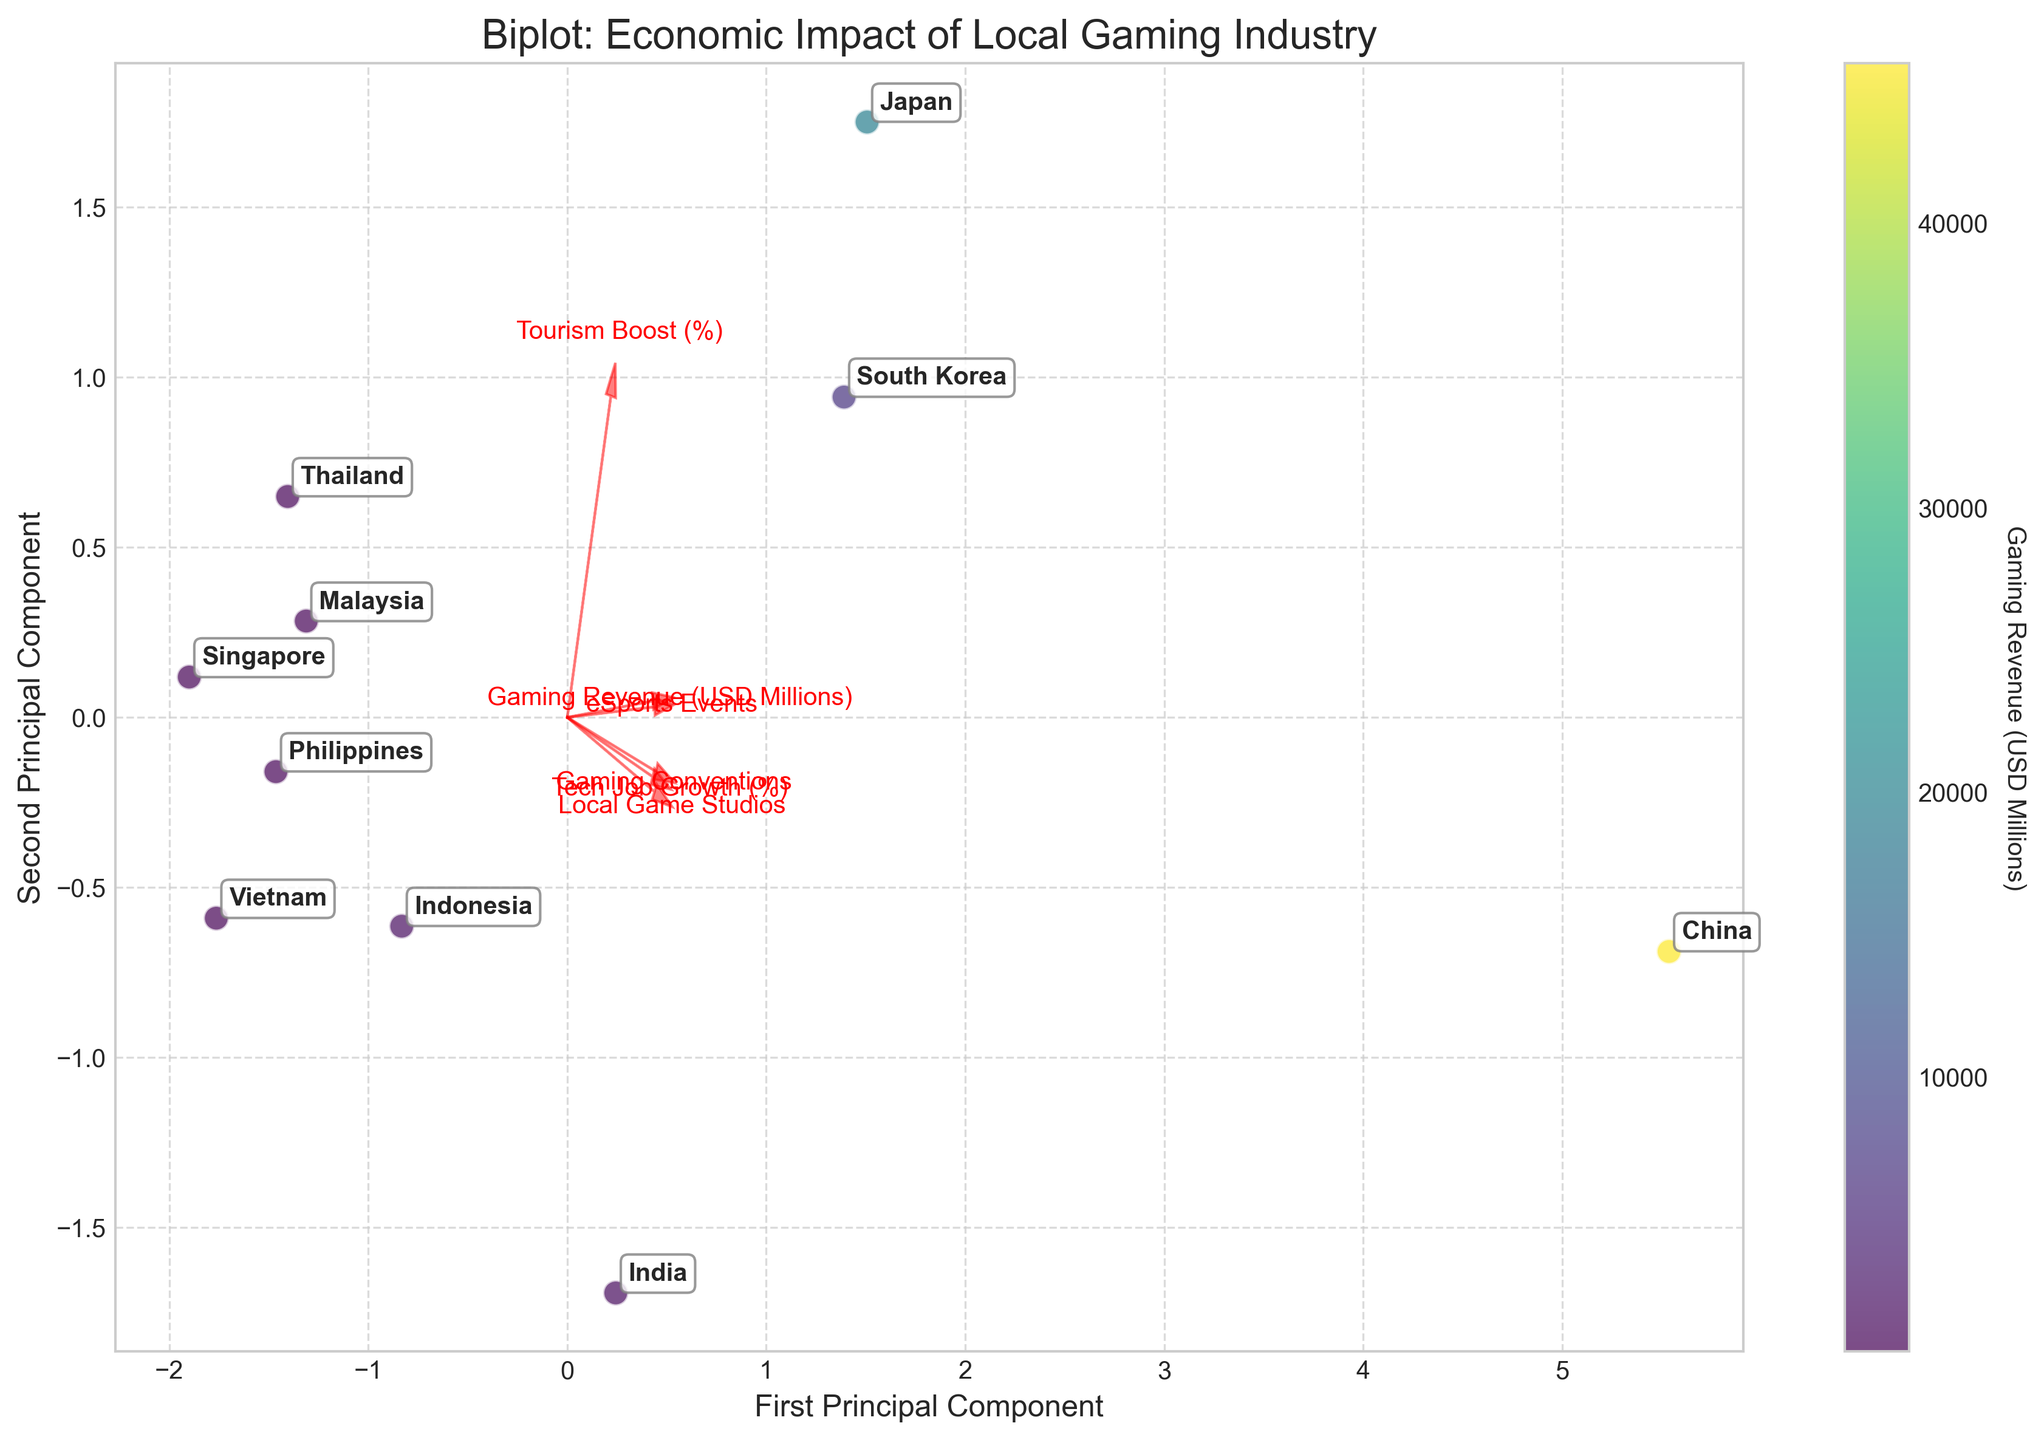What is the title of the plot? The title is usually placed at the top of the plot where it summarizes the main focus of the visualization in one line.
Answer: Biplot: Economic Impact of Local Gaming Industry How many countries are represented in the plot? Check the number of distinct annotations added on the plot for each data point representing a country.
Answer: 10 Which country has the highest gaming revenue based on the color map? Identify the data point with the deepest color corresponding to the highest value on the color map, and refer to its annotation.
Answer: China What are the labels of the axes? The labels are typically found along the sides of the plot; the x-axis label is at the bottom, and the y-axis label is on the left side.
Answer: First Principal Component and Second Principal Component Which feature is represented by the longest red arrow? The longest arrow indicates the feature with the greatest influence on the principal components. Identify the feature name next to this arrow.
Answer: Gaming Revenue (USD Millions) Which two countries seem to have the most similar impact according to the principal components? Look for data points that are closest to each other in the scatter plot as they share a similar projection in the PCA space.
Answer: Malaysia and Philippines What is the relationship between 'Tourism Boost (%)' and 'Local Game Studios'? Observe the directions of their arrows. If the arrows are aligned or pointing similarly, they are positively correlated; if reversed, negatively correlated. If perpendicular, they are uncorrelated.
Answer: Negatively correlated How many eSports Events does the country with the highest 'Tech Job Growth (%)' host? Identify which country has the highest value for 'Tech Job Growth (%)' based on the feature vector's direction ('Tech Job Growth (%)'), then locate data point's country and its corresponding eSports Events count.
Answer: China, 112 Which two features have the most orthogonal arrows, indicating the least correlation? Compare the angles between all feature vectors (arrows). The pair of arrows with an angle closest to 90 degrees are least correlated.
Answer: Local Game Studios and Gaming Conventions How does the economic impact of gaming in India compare to South Korea according to the principal components? Locate India's and South Korea's data points. Observe their positions in the PCA space relative to each other, considering both Principal Components.
Answer: India has a larger projection along the First Principal Component but is closer on the Second Principal Component compared to South Korea 